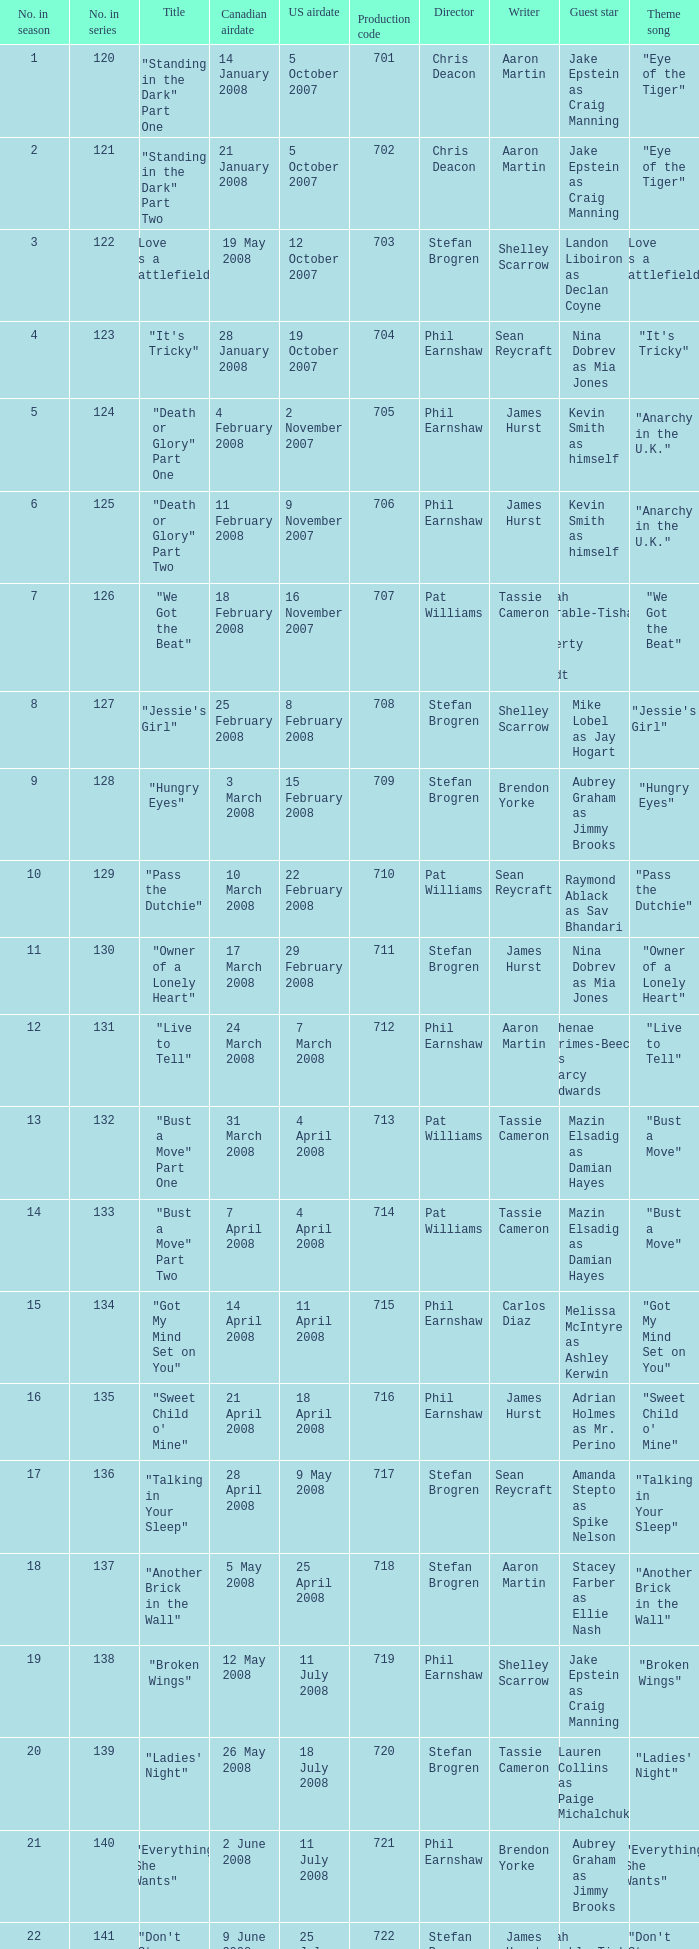The U.S. airdate of 4 april 2008 had a production code of what? 714.0. 